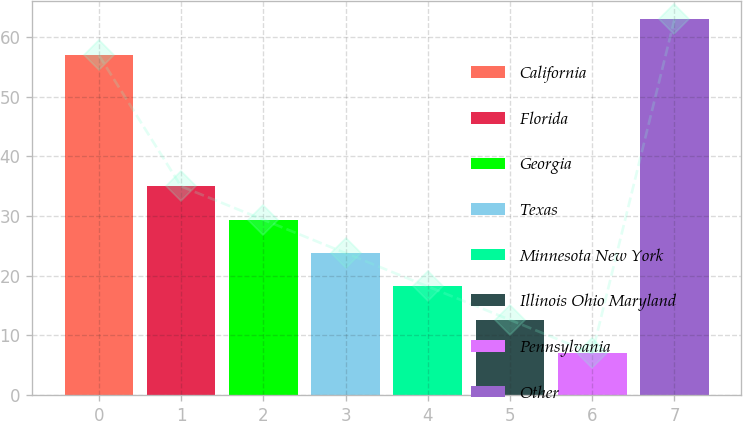<chart> <loc_0><loc_0><loc_500><loc_500><bar_chart><fcel>California<fcel>Florida<fcel>Georgia<fcel>Texas<fcel>Minnesota New York<fcel>Illinois Ohio Maryland<fcel>Pennsylvania<fcel>Other<nl><fcel>57<fcel>35<fcel>29.4<fcel>23.8<fcel>18.2<fcel>12.6<fcel>7<fcel>63<nl></chart> 